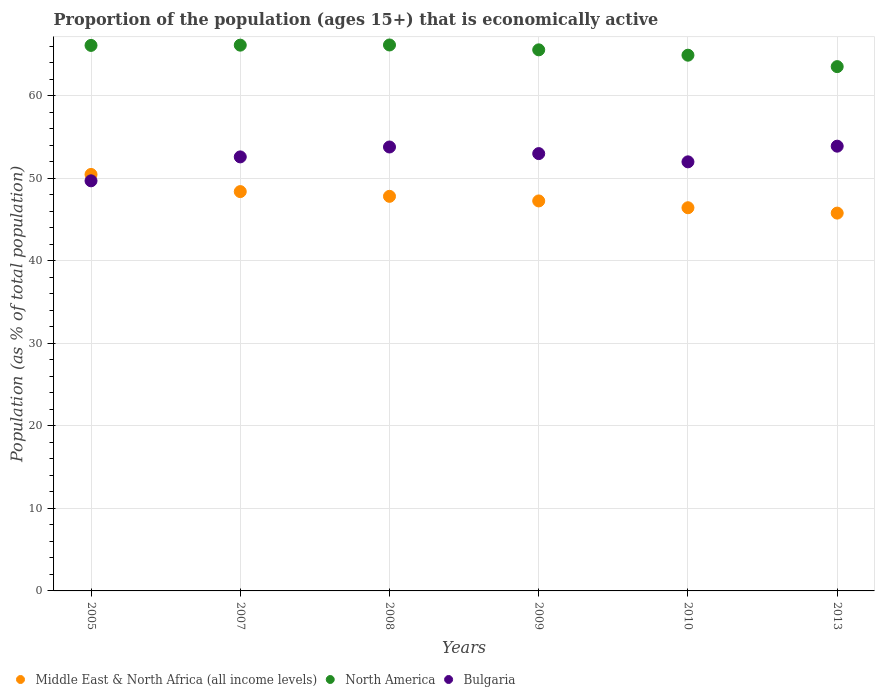Is the number of dotlines equal to the number of legend labels?
Provide a succinct answer. Yes. What is the proportion of the population that is economically active in Middle East & North Africa (all income levels) in 2010?
Your answer should be compact. 46.44. Across all years, what is the maximum proportion of the population that is economically active in North America?
Offer a very short reply. 66.16. Across all years, what is the minimum proportion of the population that is economically active in North America?
Offer a very short reply. 63.54. In which year was the proportion of the population that is economically active in Bulgaria minimum?
Provide a succinct answer. 2005. What is the total proportion of the population that is economically active in Bulgaria in the graph?
Ensure brevity in your answer.  315. What is the difference between the proportion of the population that is economically active in Middle East & North Africa (all income levels) in 2008 and that in 2010?
Your answer should be compact. 1.38. What is the difference between the proportion of the population that is economically active in North America in 2013 and the proportion of the population that is economically active in Middle East & North Africa (all income levels) in 2007?
Keep it short and to the point. 15.15. What is the average proportion of the population that is economically active in Bulgaria per year?
Keep it short and to the point. 52.5. In the year 2005, what is the difference between the proportion of the population that is economically active in Bulgaria and proportion of the population that is economically active in North America?
Offer a very short reply. -16.41. In how many years, is the proportion of the population that is economically active in Bulgaria greater than 34 %?
Your answer should be compact. 6. What is the ratio of the proportion of the population that is economically active in Bulgaria in 2005 to that in 2007?
Offer a terse response. 0.94. Is the proportion of the population that is economically active in Middle East & North Africa (all income levels) in 2008 less than that in 2010?
Offer a very short reply. No. Is the difference between the proportion of the population that is economically active in Bulgaria in 2008 and 2010 greater than the difference between the proportion of the population that is economically active in North America in 2008 and 2010?
Your answer should be compact. Yes. What is the difference between the highest and the second highest proportion of the population that is economically active in Bulgaria?
Your answer should be very brief. 0.1. What is the difference between the highest and the lowest proportion of the population that is economically active in Middle East & North Africa (all income levels)?
Offer a very short reply. 4.69. In how many years, is the proportion of the population that is economically active in Bulgaria greater than the average proportion of the population that is economically active in Bulgaria taken over all years?
Offer a very short reply. 4. Is the proportion of the population that is economically active in North America strictly greater than the proportion of the population that is economically active in Middle East & North Africa (all income levels) over the years?
Your answer should be very brief. Yes. Does the graph contain any zero values?
Give a very brief answer. No. How many legend labels are there?
Your response must be concise. 3. What is the title of the graph?
Give a very brief answer. Proportion of the population (ages 15+) that is economically active. Does "East Asia (all income levels)" appear as one of the legend labels in the graph?
Keep it short and to the point. No. What is the label or title of the Y-axis?
Your response must be concise. Population (as % of total population). What is the Population (as % of total population) in Middle East & North Africa (all income levels) in 2005?
Make the answer very short. 50.47. What is the Population (as % of total population) in North America in 2005?
Provide a succinct answer. 66.11. What is the Population (as % of total population) of Bulgaria in 2005?
Your answer should be very brief. 49.7. What is the Population (as % of total population) in Middle East & North Africa (all income levels) in 2007?
Provide a short and direct response. 48.39. What is the Population (as % of total population) of North America in 2007?
Offer a terse response. 66.14. What is the Population (as % of total population) of Bulgaria in 2007?
Your response must be concise. 52.6. What is the Population (as % of total population) of Middle East & North Africa (all income levels) in 2008?
Ensure brevity in your answer.  47.82. What is the Population (as % of total population) of North America in 2008?
Ensure brevity in your answer.  66.16. What is the Population (as % of total population) in Bulgaria in 2008?
Make the answer very short. 53.8. What is the Population (as % of total population) of Middle East & North Africa (all income levels) in 2009?
Make the answer very short. 47.26. What is the Population (as % of total population) of North America in 2009?
Your answer should be compact. 65.57. What is the Population (as % of total population) of Middle East & North Africa (all income levels) in 2010?
Offer a terse response. 46.44. What is the Population (as % of total population) in North America in 2010?
Your answer should be very brief. 64.93. What is the Population (as % of total population) of Bulgaria in 2010?
Make the answer very short. 52. What is the Population (as % of total population) of Middle East & North Africa (all income levels) in 2013?
Keep it short and to the point. 45.79. What is the Population (as % of total population) of North America in 2013?
Offer a very short reply. 63.54. What is the Population (as % of total population) in Bulgaria in 2013?
Provide a succinct answer. 53.9. Across all years, what is the maximum Population (as % of total population) of Middle East & North Africa (all income levels)?
Make the answer very short. 50.47. Across all years, what is the maximum Population (as % of total population) in North America?
Offer a terse response. 66.16. Across all years, what is the maximum Population (as % of total population) in Bulgaria?
Make the answer very short. 53.9. Across all years, what is the minimum Population (as % of total population) in Middle East & North Africa (all income levels)?
Keep it short and to the point. 45.79. Across all years, what is the minimum Population (as % of total population) in North America?
Keep it short and to the point. 63.54. Across all years, what is the minimum Population (as % of total population) of Bulgaria?
Keep it short and to the point. 49.7. What is the total Population (as % of total population) of Middle East & North Africa (all income levels) in the graph?
Provide a succinct answer. 286.18. What is the total Population (as % of total population) of North America in the graph?
Provide a succinct answer. 392.46. What is the total Population (as % of total population) in Bulgaria in the graph?
Ensure brevity in your answer.  315. What is the difference between the Population (as % of total population) of Middle East & North Africa (all income levels) in 2005 and that in 2007?
Make the answer very short. 2.08. What is the difference between the Population (as % of total population) in North America in 2005 and that in 2007?
Offer a terse response. -0.03. What is the difference between the Population (as % of total population) in Bulgaria in 2005 and that in 2007?
Offer a very short reply. -2.9. What is the difference between the Population (as % of total population) of Middle East & North Africa (all income levels) in 2005 and that in 2008?
Ensure brevity in your answer.  2.65. What is the difference between the Population (as % of total population) in North America in 2005 and that in 2008?
Give a very brief answer. -0.05. What is the difference between the Population (as % of total population) in Bulgaria in 2005 and that in 2008?
Keep it short and to the point. -4.1. What is the difference between the Population (as % of total population) of Middle East & North Africa (all income levels) in 2005 and that in 2009?
Keep it short and to the point. 3.21. What is the difference between the Population (as % of total population) of North America in 2005 and that in 2009?
Offer a very short reply. 0.54. What is the difference between the Population (as % of total population) in Middle East & North Africa (all income levels) in 2005 and that in 2010?
Keep it short and to the point. 4.04. What is the difference between the Population (as % of total population) in North America in 2005 and that in 2010?
Make the answer very short. 1.19. What is the difference between the Population (as % of total population) of Bulgaria in 2005 and that in 2010?
Ensure brevity in your answer.  -2.3. What is the difference between the Population (as % of total population) of Middle East & North Africa (all income levels) in 2005 and that in 2013?
Offer a very short reply. 4.69. What is the difference between the Population (as % of total population) of North America in 2005 and that in 2013?
Your answer should be very brief. 2.57. What is the difference between the Population (as % of total population) of Bulgaria in 2005 and that in 2013?
Provide a short and direct response. -4.2. What is the difference between the Population (as % of total population) in Middle East & North Africa (all income levels) in 2007 and that in 2008?
Keep it short and to the point. 0.57. What is the difference between the Population (as % of total population) in North America in 2007 and that in 2008?
Keep it short and to the point. -0.02. What is the difference between the Population (as % of total population) of Bulgaria in 2007 and that in 2008?
Keep it short and to the point. -1.2. What is the difference between the Population (as % of total population) of Middle East & North Africa (all income levels) in 2007 and that in 2009?
Provide a short and direct response. 1.13. What is the difference between the Population (as % of total population) of North America in 2007 and that in 2009?
Your response must be concise. 0.57. What is the difference between the Population (as % of total population) of Middle East & North Africa (all income levels) in 2007 and that in 2010?
Your answer should be compact. 1.96. What is the difference between the Population (as % of total population) of North America in 2007 and that in 2010?
Give a very brief answer. 1.22. What is the difference between the Population (as % of total population) of Middle East & North Africa (all income levels) in 2007 and that in 2013?
Make the answer very short. 2.61. What is the difference between the Population (as % of total population) in North America in 2007 and that in 2013?
Your answer should be very brief. 2.6. What is the difference between the Population (as % of total population) in Bulgaria in 2007 and that in 2013?
Offer a terse response. -1.3. What is the difference between the Population (as % of total population) of Middle East & North Africa (all income levels) in 2008 and that in 2009?
Your answer should be very brief. 0.56. What is the difference between the Population (as % of total population) in North America in 2008 and that in 2009?
Give a very brief answer. 0.59. What is the difference between the Population (as % of total population) of Bulgaria in 2008 and that in 2009?
Your response must be concise. 0.8. What is the difference between the Population (as % of total population) of Middle East & North Africa (all income levels) in 2008 and that in 2010?
Offer a terse response. 1.38. What is the difference between the Population (as % of total population) of North America in 2008 and that in 2010?
Your response must be concise. 1.24. What is the difference between the Population (as % of total population) in Middle East & North Africa (all income levels) in 2008 and that in 2013?
Make the answer very short. 2.03. What is the difference between the Population (as % of total population) of North America in 2008 and that in 2013?
Your answer should be very brief. 2.62. What is the difference between the Population (as % of total population) of Bulgaria in 2008 and that in 2013?
Offer a terse response. -0.1. What is the difference between the Population (as % of total population) in Middle East & North Africa (all income levels) in 2009 and that in 2010?
Ensure brevity in your answer.  0.82. What is the difference between the Population (as % of total population) in North America in 2009 and that in 2010?
Your answer should be compact. 0.65. What is the difference between the Population (as % of total population) in Middle East & North Africa (all income levels) in 2009 and that in 2013?
Offer a very short reply. 1.48. What is the difference between the Population (as % of total population) in North America in 2009 and that in 2013?
Give a very brief answer. 2.03. What is the difference between the Population (as % of total population) in Middle East & North Africa (all income levels) in 2010 and that in 2013?
Give a very brief answer. 0.65. What is the difference between the Population (as % of total population) of North America in 2010 and that in 2013?
Your answer should be compact. 1.38. What is the difference between the Population (as % of total population) in Middle East & North Africa (all income levels) in 2005 and the Population (as % of total population) in North America in 2007?
Give a very brief answer. -15.67. What is the difference between the Population (as % of total population) of Middle East & North Africa (all income levels) in 2005 and the Population (as % of total population) of Bulgaria in 2007?
Your response must be concise. -2.13. What is the difference between the Population (as % of total population) of North America in 2005 and the Population (as % of total population) of Bulgaria in 2007?
Provide a short and direct response. 13.51. What is the difference between the Population (as % of total population) in Middle East & North Africa (all income levels) in 2005 and the Population (as % of total population) in North America in 2008?
Provide a short and direct response. -15.69. What is the difference between the Population (as % of total population) in Middle East & North Africa (all income levels) in 2005 and the Population (as % of total population) in Bulgaria in 2008?
Your response must be concise. -3.33. What is the difference between the Population (as % of total population) in North America in 2005 and the Population (as % of total population) in Bulgaria in 2008?
Provide a short and direct response. 12.31. What is the difference between the Population (as % of total population) in Middle East & North Africa (all income levels) in 2005 and the Population (as % of total population) in North America in 2009?
Keep it short and to the point. -15.1. What is the difference between the Population (as % of total population) in Middle East & North Africa (all income levels) in 2005 and the Population (as % of total population) in Bulgaria in 2009?
Offer a terse response. -2.53. What is the difference between the Population (as % of total population) in North America in 2005 and the Population (as % of total population) in Bulgaria in 2009?
Keep it short and to the point. 13.11. What is the difference between the Population (as % of total population) of Middle East & North Africa (all income levels) in 2005 and the Population (as % of total population) of North America in 2010?
Provide a succinct answer. -14.45. What is the difference between the Population (as % of total population) in Middle East & North Africa (all income levels) in 2005 and the Population (as % of total population) in Bulgaria in 2010?
Offer a terse response. -1.53. What is the difference between the Population (as % of total population) in North America in 2005 and the Population (as % of total population) in Bulgaria in 2010?
Make the answer very short. 14.11. What is the difference between the Population (as % of total population) of Middle East & North Africa (all income levels) in 2005 and the Population (as % of total population) of North America in 2013?
Keep it short and to the point. -13.07. What is the difference between the Population (as % of total population) of Middle East & North Africa (all income levels) in 2005 and the Population (as % of total population) of Bulgaria in 2013?
Offer a terse response. -3.43. What is the difference between the Population (as % of total population) in North America in 2005 and the Population (as % of total population) in Bulgaria in 2013?
Keep it short and to the point. 12.21. What is the difference between the Population (as % of total population) in Middle East & North Africa (all income levels) in 2007 and the Population (as % of total population) in North America in 2008?
Provide a short and direct response. -17.77. What is the difference between the Population (as % of total population) of Middle East & North Africa (all income levels) in 2007 and the Population (as % of total population) of Bulgaria in 2008?
Your response must be concise. -5.41. What is the difference between the Population (as % of total population) of North America in 2007 and the Population (as % of total population) of Bulgaria in 2008?
Keep it short and to the point. 12.34. What is the difference between the Population (as % of total population) of Middle East & North Africa (all income levels) in 2007 and the Population (as % of total population) of North America in 2009?
Offer a terse response. -17.18. What is the difference between the Population (as % of total population) in Middle East & North Africa (all income levels) in 2007 and the Population (as % of total population) in Bulgaria in 2009?
Provide a succinct answer. -4.61. What is the difference between the Population (as % of total population) in North America in 2007 and the Population (as % of total population) in Bulgaria in 2009?
Provide a short and direct response. 13.14. What is the difference between the Population (as % of total population) of Middle East & North Africa (all income levels) in 2007 and the Population (as % of total population) of North America in 2010?
Ensure brevity in your answer.  -16.53. What is the difference between the Population (as % of total population) of Middle East & North Africa (all income levels) in 2007 and the Population (as % of total population) of Bulgaria in 2010?
Ensure brevity in your answer.  -3.61. What is the difference between the Population (as % of total population) in North America in 2007 and the Population (as % of total population) in Bulgaria in 2010?
Provide a succinct answer. 14.14. What is the difference between the Population (as % of total population) of Middle East & North Africa (all income levels) in 2007 and the Population (as % of total population) of North America in 2013?
Offer a very short reply. -15.15. What is the difference between the Population (as % of total population) of Middle East & North Africa (all income levels) in 2007 and the Population (as % of total population) of Bulgaria in 2013?
Offer a very short reply. -5.51. What is the difference between the Population (as % of total population) of North America in 2007 and the Population (as % of total population) of Bulgaria in 2013?
Provide a succinct answer. 12.24. What is the difference between the Population (as % of total population) in Middle East & North Africa (all income levels) in 2008 and the Population (as % of total population) in North America in 2009?
Provide a succinct answer. -17.75. What is the difference between the Population (as % of total population) in Middle East & North Africa (all income levels) in 2008 and the Population (as % of total population) in Bulgaria in 2009?
Offer a very short reply. -5.18. What is the difference between the Population (as % of total population) of North America in 2008 and the Population (as % of total population) of Bulgaria in 2009?
Offer a very short reply. 13.16. What is the difference between the Population (as % of total population) in Middle East & North Africa (all income levels) in 2008 and the Population (as % of total population) in North America in 2010?
Offer a very short reply. -17.11. What is the difference between the Population (as % of total population) in Middle East & North Africa (all income levels) in 2008 and the Population (as % of total population) in Bulgaria in 2010?
Your answer should be very brief. -4.18. What is the difference between the Population (as % of total population) of North America in 2008 and the Population (as % of total population) of Bulgaria in 2010?
Offer a terse response. 14.16. What is the difference between the Population (as % of total population) in Middle East & North Africa (all income levels) in 2008 and the Population (as % of total population) in North America in 2013?
Offer a terse response. -15.72. What is the difference between the Population (as % of total population) in Middle East & North Africa (all income levels) in 2008 and the Population (as % of total population) in Bulgaria in 2013?
Your response must be concise. -6.08. What is the difference between the Population (as % of total population) in North America in 2008 and the Population (as % of total population) in Bulgaria in 2013?
Ensure brevity in your answer.  12.26. What is the difference between the Population (as % of total population) in Middle East & North Africa (all income levels) in 2009 and the Population (as % of total population) in North America in 2010?
Your answer should be compact. -17.66. What is the difference between the Population (as % of total population) in Middle East & North Africa (all income levels) in 2009 and the Population (as % of total population) in Bulgaria in 2010?
Offer a terse response. -4.74. What is the difference between the Population (as % of total population) in North America in 2009 and the Population (as % of total population) in Bulgaria in 2010?
Give a very brief answer. 13.57. What is the difference between the Population (as % of total population) of Middle East & North Africa (all income levels) in 2009 and the Population (as % of total population) of North America in 2013?
Make the answer very short. -16.28. What is the difference between the Population (as % of total population) of Middle East & North Africa (all income levels) in 2009 and the Population (as % of total population) of Bulgaria in 2013?
Keep it short and to the point. -6.64. What is the difference between the Population (as % of total population) of North America in 2009 and the Population (as % of total population) of Bulgaria in 2013?
Offer a very short reply. 11.67. What is the difference between the Population (as % of total population) in Middle East & North Africa (all income levels) in 2010 and the Population (as % of total population) in North America in 2013?
Provide a short and direct response. -17.1. What is the difference between the Population (as % of total population) of Middle East & North Africa (all income levels) in 2010 and the Population (as % of total population) of Bulgaria in 2013?
Provide a short and direct response. -7.46. What is the difference between the Population (as % of total population) of North America in 2010 and the Population (as % of total population) of Bulgaria in 2013?
Your answer should be compact. 11.03. What is the average Population (as % of total population) of Middle East & North Africa (all income levels) per year?
Your response must be concise. 47.7. What is the average Population (as % of total population) of North America per year?
Offer a terse response. 65.41. What is the average Population (as % of total population) in Bulgaria per year?
Your answer should be very brief. 52.5. In the year 2005, what is the difference between the Population (as % of total population) in Middle East & North Africa (all income levels) and Population (as % of total population) in North America?
Keep it short and to the point. -15.64. In the year 2005, what is the difference between the Population (as % of total population) of Middle East & North Africa (all income levels) and Population (as % of total population) of Bulgaria?
Offer a terse response. 0.77. In the year 2005, what is the difference between the Population (as % of total population) of North America and Population (as % of total population) of Bulgaria?
Give a very brief answer. 16.41. In the year 2007, what is the difference between the Population (as % of total population) of Middle East & North Africa (all income levels) and Population (as % of total population) of North America?
Your answer should be compact. -17.75. In the year 2007, what is the difference between the Population (as % of total population) of Middle East & North Africa (all income levels) and Population (as % of total population) of Bulgaria?
Give a very brief answer. -4.21. In the year 2007, what is the difference between the Population (as % of total population) in North America and Population (as % of total population) in Bulgaria?
Ensure brevity in your answer.  13.54. In the year 2008, what is the difference between the Population (as % of total population) in Middle East & North Africa (all income levels) and Population (as % of total population) in North America?
Your answer should be compact. -18.34. In the year 2008, what is the difference between the Population (as % of total population) of Middle East & North Africa (all income levels) and Population (as % of total population) of Bulgaria?
Make the answer very short. -5.98. In the year 2008, what is the difference between the Population (as % of total population) of North America and Population (as % of total population) of Bulgaria?
Your answer should be compact. 12.36. In the year 2009, what is the difference between the Population (as % of total population) in Middle East & North Africa (all income levels) and Population (as % of total population) in North America?
Offer a terse response. -18.31. In the year 2009, what is the difference between the Population (as % of total population) of Middle East & North Africa (all income levels) and Population (as % of total population) of Bulgaria?
Offer a terse response. -5.74. In the year 2009, what is the difference between the Population (as % of total population) in North America and Population (as % of total population) in Bulgaria?
Keep it short and to the point. 12.57. In the year 2010, what is the difference between the Population (as % of total population) in Middle East & North Africa (all income levels) and Population (as % of total population) in North America?
Make the answer very short. -18.49. In the year 2010, what is the difference between the Population (as % of total population) in Middle East & North Africa (all income levels) and Population (as % of total population) in Bulgaria?
Offer a terse response. -5.56. In the year 2010, what is the difference between the Population (as % of total population) of North America and Population (as % of total population) of Bulgaria?
Your answer should be very brief. 12.93. In the year 2013, what is the difference between the Population (as % of total population) of Middle East & North Africa (all income levels) and Population (as % of total population) of North America?
Keep it short and to the point. -17.75. In the year 2013, what is the difference between the Population (as % of total population) of Middle East & North Africa (all income levels) and Population (as % of total population) of Bulgaria?
Your answer should be very brief. -8.11. In the year 2013, what is the difference between the Population (as % of total population) in North America and Population (as % of total population) in Bulgaria?
Give a very brief answer. 9.64. What is the ratio of the Population (as % of total population) in Middle East & North Africa (all income levels) in 2005 to that in 2007?
Ensure brevity in your answer.  1.04. What is the ratio of the Population (as % of total population) of Bulgaria in 2005 to that in 2007?
Your answer should be compact. 0.94. What is the ratio of the Population (as % of total population) in Middle East & North Africa (all income levels) in 2005 to that in 2008?
Your answer should be compact. 1.06. What is the ratio of the Population (as % of total population) of North America in 2005 to that in 2008?
Ensure brevity in your answer.  1. What is the ratio of the Population (as % of total population) in Bulgaria in 2005 to that in 2008?
Give a very brief answer. 0.92. What is the ratio of the Population (as % of total population) in Middle East & North Africa (all income levels) in 2005 to that in 2009?
Offer a terse response. 1.07. What is the ratio of the Population (as % of total population) of North America in 2005 to that in 2009?
Your response must be concise. 1.01. What is the ratio of the Population (as % of total population) of Bulgaria in 2005 to that in 2009?
Your response must be concise. 0.94. What is the ratio of the Population (as % of total population) of Middle East & North Africa (all income levels) in 2005 to that in 2010?
Provide a short and direct response. 1.09. What is the ratio of the Population (as % of total population) of North America in 2005 to that in 2010?
Offer a very short reply. 1.02. What is the ratio of the Population (as % of total population) in Bulgaria in 2005 to that in 2010?
Keep it short and to the point. 0.96. What is the ratio of the Population (as % of total population) in Middle East & North Africa (all income levels) in 2005 to that in 2013?
Provide a short and direct response. 1.1. What is the ratio of the Population (as % of total population) in North America in 2005 to that in 2013?
Ensure brevity in your answer.  1.04. What is the ratio of the Population (as % of total population) in Bulgaria in 2005 to that in 2013?
Provide a succinct answer. 0.92. What is the ratio of the Population (as % of total population) of Middle East & North Africa (all income levels) in 2007 to that in 2008?
Give a very brief answer. 1.01. What is the ratio of the Population (as % of total population) in Bulgaria in 2007 to that in 2008?
Offer a very short reply. 0.98. What is the ratio of the Population (as % of total population) in Middle East & North Africa (all income levels) in 2007 to that in 2009?
Your answer should be compact. 1.02. What is the ratio of the Population (as % of total population) in North America in 2007 to that in 2009?
Offer a terse response. 1.01. What is the ratio of the Population (as % of total population) of Bulgaria in 2007 to that in 2009?
Provide a short and direct response. 0.99. What is the ratio of the Population (as % of total population) of Middle East & North Africa (all income levels) in 2007 to that in 2010?
Your response must be concise. 1.04. What is the ratio of the Population (as % of total population) in North America in 2007 to that in 2010?
Offer a terse response. 1.02. What is the ratio of the Population (as % of total population) in Bulgaria in 2007 to that in 2010?
Ensure brevity in your answer.  1.01. What is the ratio of the Population (as % of total population) of Middle East & North Africa (all income levels) in 2007 to that in 2013?
Make the answer very short. 1.06. What is the ratio of the Population (as % of total population) in North America in 2007 to that in 2013?
Offer a very short reply. 1.04. What is the ratio of the Population (as % of total population) in Bulgaria in 2007 to that in 2013?
Provide a succinct answer. 0.98. What is the ratio of the Population (as % of total population) of Middle East & North Africa (all income levels) in 2008 to that in 2009?
Keep it short and to the point. 1.01. What is the ratio of the Population (as % of total population) of North America in 2008 to that in 2009?
Provide a short and direct response. 1.01. What is the ratio of the Population (as % of total population) of Bulgaria in 2008 to that in 2009?
Ensure brevity in your answer.  1.02. What is the ratio of the Population (as % of total population) in Middle East & North Africa (all income levels) in 2008 to that in 2010?
Keep it short and to the point. 1.03. What is the ratio of the Population (as % of total population) of North America in 2008 to that in 2010?
Keep it short and to the point. 1.02. What is the ratio of the Population (as % of total population) of Bulgaria in 2008 to that in 2010?
Provide a succinct answer. 1.03. What is the ratio of the Population (as % of total population) of Middle East & North Africa (all income levels) in 2008 to that in 2013?
Give a very brief answer. 1.04. What is the ratio of the Population (as % of total population) in North America in 2008 to that in 2013?
Your answer should be very brief. 1.04. What is the ratio of the Population (as % of total population) of Bulgaria in 2008 to that in 2013?
Provide a succinct answer. 1. What is the ratio of the Population (as % of total population) in Middle East & North Africa (all income levels) in 2009 to that in 2010?
Keep it short and to the point. 1.02. What is the ratio of the Population (as % of total population) in North America in 2009 to that in 2010?
Make the answer very short. 1.01. What is the ratio of the Population (as % of total population) of Bulgaria in 2009 to that in 2010?
Provide a succinct answer. 1.02. What is the ratio of the Population (as % of total population) of Middle East & North Africa (all income levels) in 2009 to that in 2013?
Ensure brevity in your answer.  1.03. What is the ratio of the Population (as % of total population) in North America in 2009 to that in 2013?
Give a very brief answer. 1.03. What is the ratio of the Population (as % of total population) in Bulgaria in 2009 to that in 2013?
Offer a very short reply. 0.98. What is the ratio of the Population (as % of total population) of Middle East & North Africa (all income levels) in 2010 to that in 2013?
Give a very brief answer. 1.01. What is the ratio of the Population (as % of total population) in North America in 2010 to that in 2013?
Your answer should be compact. 1.02. What is the ratio of the Population (as % of total population) in Bulgaria in 2010 to that in 2013?
Your response must be concise. 0.96. What is the difference between the highest and the second highest Population (as % of total population) of Middle East & North Africa (all income levels)?
Provide a succinct answer. 2.08. What is the difference between the highest and the second highest Population (as % of total population) of North America?
Keep it short and to the point. 0.02. What is the difference between the highest and the lowest Population (as % of total population) in Middle East & North Africa (all income levels)?
Ensure brevity in your answer.  4.69. What is the difference between the highest and the lowest Population (as % of total population) in North America?
Provide a succinct answer. 2.62. What is the difference between the highest and the lowest Population (as % of total population) in Bulgaria?
Provide a succinct answer. 4.2. 